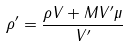<formula> <loc_0><loc_0><loc_500><loc_500>\rho ^ { \prime } = \frac { \rho V + M V ^ { \prime } \mu } { V ^ { \prime } }</formula> 